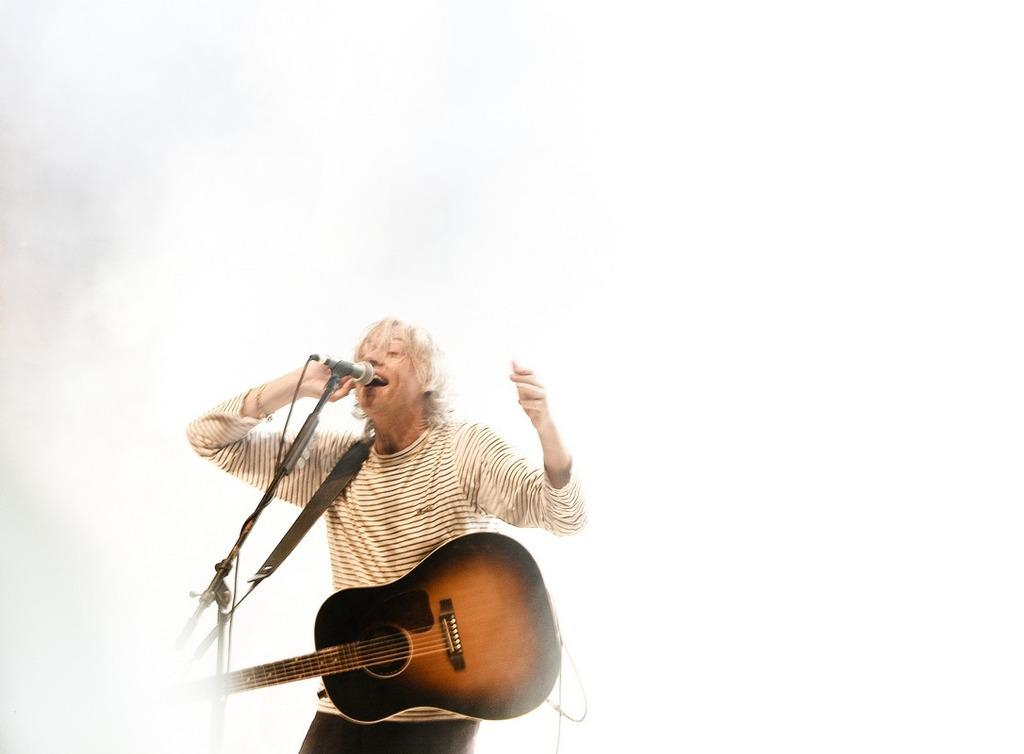What is the man in the picture doing? The man is singing a song. What instrument is the man holding in the image? The man is holding a guitar. What color is the wall in the background of the image? The wall in the background of the image is white. How much salt is on the man's guitar in the image? There is no salt present on the man's guitar in the image. 